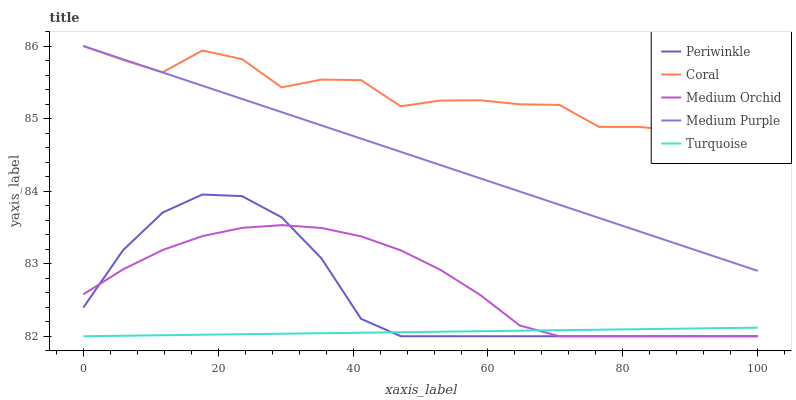Does Medium Orchid have the minimum area under the curve?
Answer yes or no. No. Does Medium Orchid have the maximum area under the curve?
Answer yes or no. No. Is Medium Orchid the smoothest?
Answer yes or no. No. Is Medium Orchid the roughest?
Answer yes or no. No. Does Coral have the lowest value?
Answer yes or no. No. Does Medium Orchid have the highest value?
Answer yes or no. No. Is Periwinkle less than Coral?
Answer yes or no. Yes. Is Medium Purple greater than Medium Orchid?
Answer yes or no. Yes. Does Periwinkle intersect Coral?
Answer yes or no. No. 